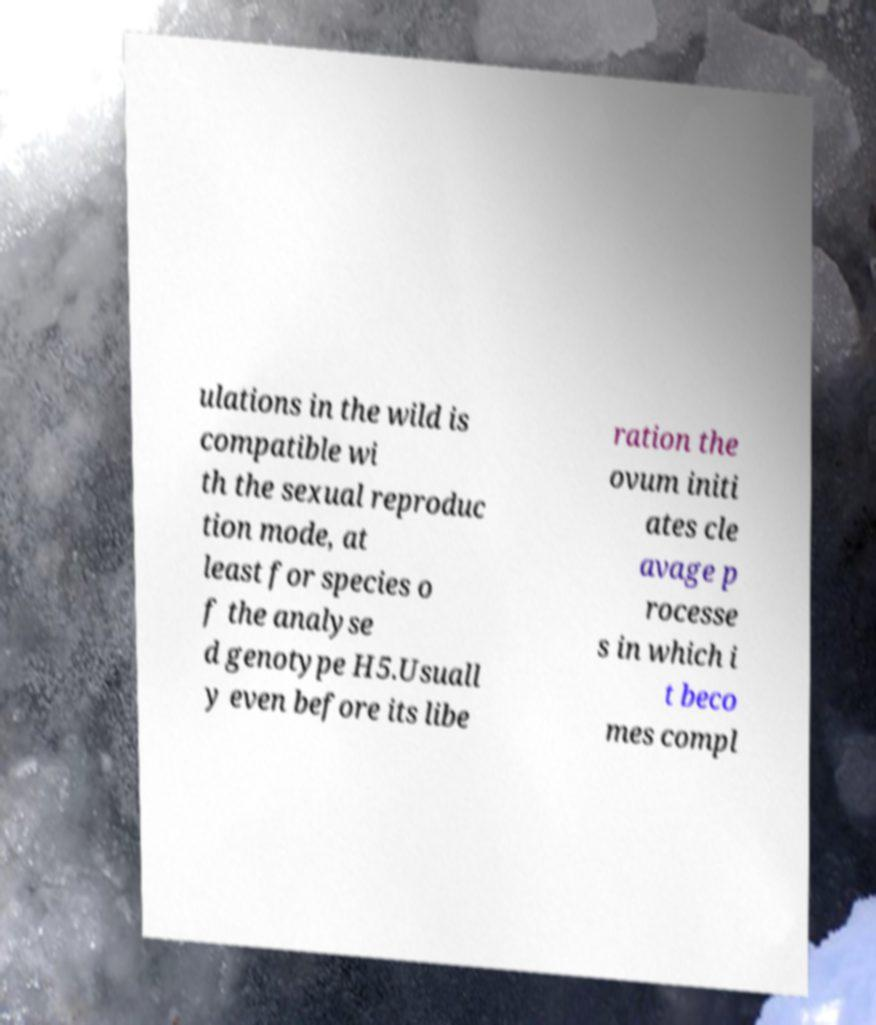Can you accurately transcribe the text from the provided image for me? ulations in the wild is compatible wi th the sexual reproduc tion mode, at least for species o f the analyse d genotype H5.Usuall y even before its libe ration the ovum initi ates cle avage p rocesse s in which i t beco mes compl 